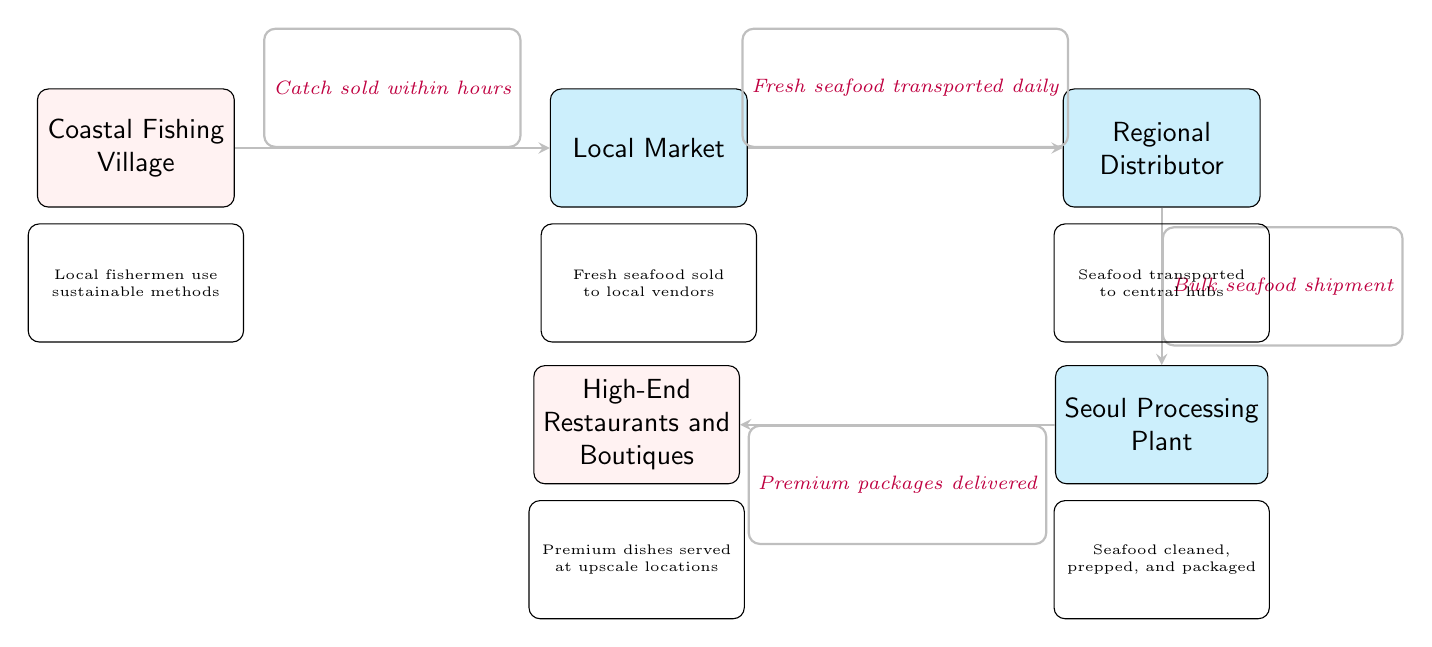What is the starting point of the seafood supply chain? The starting point of the seafood supply chain is indicated by the first node in the diagram, which is "Coastal Fishing Village."
Answer: Coastal Fishing Village How many main nodes are in the diagram? The diagram contains five main nodes that represent different stages in the seafood supply chain: Coastal Fishing Village, Local Market, Regional Distributor, Seoul Processing Plant, and High-End Restaurants and Boutiques.
Answer: 5 What does the local market receive? According to the diagram, the local market receives "Fresh seafood transported daily" from the Coastal Fishing Village.
Answer: Fresh seafood transported daily What occurs after the seafood is distributed? After the seafood is distributed, it is processed at the "Seoul Processing Plant" where it is cleaned, prepped, and packaged as indicated in the node description.
Answer: Seoul Processing Plant What is the final destination of the premium packages? The final destination of the premium packages, as described in the diagram, is the "High-End Restaurants and Boutiques" where they serve upscale dishes.
Answer: High-End Restaurants and Boutiques What is the process involved after the seafood reaches the local market? After reaching the local market, seafood is sold to local vendors, which is depicted in the description below the Local Market node.
Answer: Seafood sold to local vendors Which node describes sustainable methods? The node that describes sustainable methods is "Coastal Fishing Village," according to the information provided below the node in the diagram.
Answer: Coastal Fishing Village What type of transportation occurs from the local market to the distributor? The transportation happening from the local market to the distributor is described as "Fresh seafood transported daily" in the arrow connecting those two nodes.
Answer: Fresh seafood transported daily What is packaged at the Seoul Processing Plant? At the Seoul Processing Plant, the seafood is "cleaned, prepped, and packaged" as indicated in the node's description.
Answer: Cleaned, prepped, and packaged 